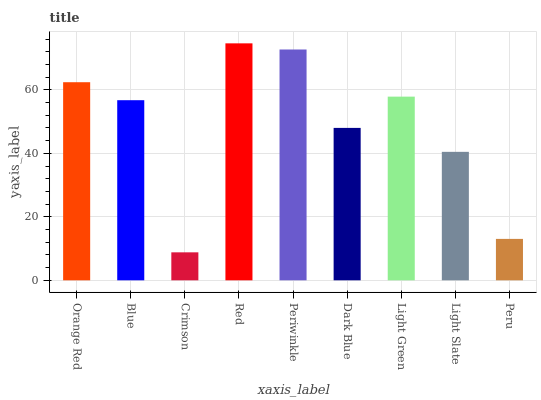Is Crimson the minimum?
Answer yes or no. Yes. Is Red the maximum?
Answer yes or no. Yes. Is Blue the minimum?
Answer yes or no. No. Is Blue the maximum?
Answer yes or no. No. Is Orange Red greater than Blue?
Answer yes or no. Yes. Is Blue less than Orange Red?
Answer yes or no. Yes. Is Blue greater than Orange Red?
Answer yes or no. No. Is Orange Red less than Blue?
Answer yes or no. No. Is Blue the high median?
Answer yes or no. Yes. Is Blue the low median?
Answer yes or no. Yes. Is Periwinkle the high median?
Answer yes or no. No. Is Peru the low median?
Answer yes or no. No. 